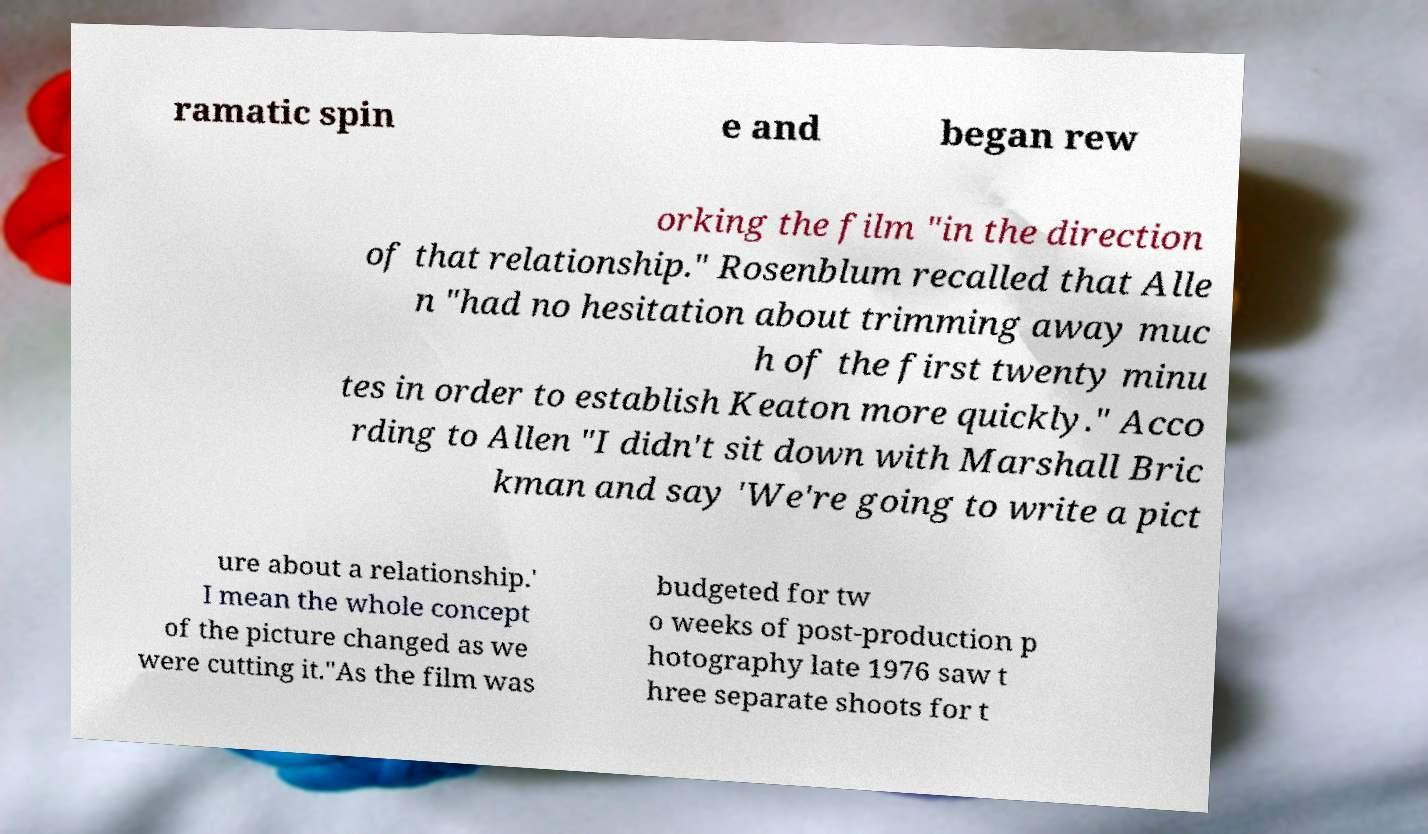There's text embedded in this image that I need extracted. Can you transcribe it verbatim? ramatic spin e and began rew orking the film "in the direction of that relationship." Rosenblum recalled that Alle n "had no hesitation about trimming away muc h of the first twenty minu tes in order to establish Keaton more quickly." Acco rding to Allen "I didn't sit down with Marshall Bric kman and say 'We're going to write a pict ure about a relationship.' I mean the whole concept of the picture changed as we were cutting it."As the film was budgeted for tw o weeks of post-production p hotography late 1976 saw t hree separate shoots for t 